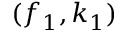<formula> <loc_0><loc_0><loc_500><loc_500>( f _ { 1 } , k _ { 1 } )</formula> 